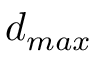Convert formula to latex. <formula><loc_0><loc_0><loc_500><loc_500>d _ { \max }</formula> 